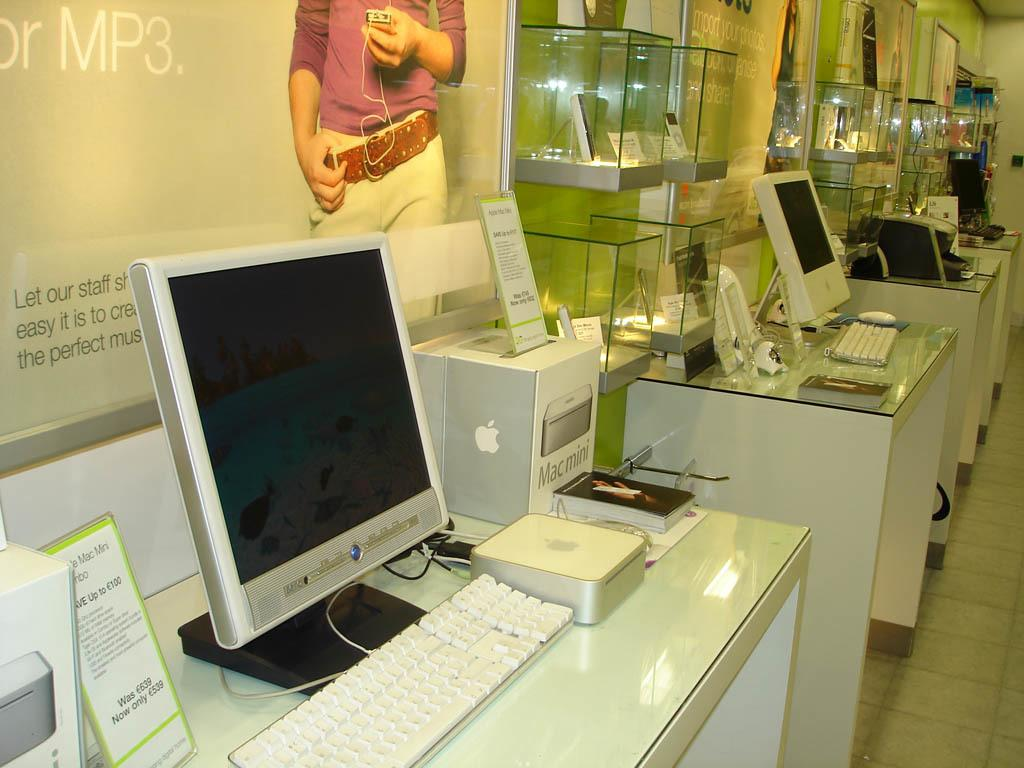Provide a one-sentence caption for the provided image. An Apple store with a variety of products including a Mac mini. 